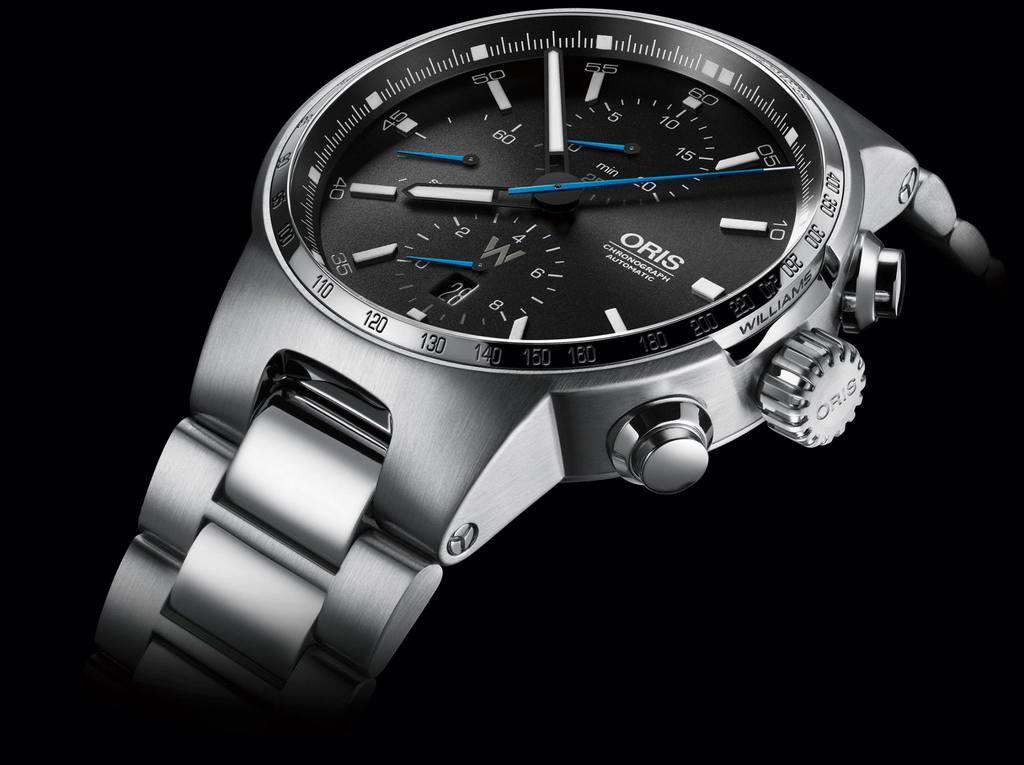Is that an oris watch?
Your response must be concise. Yes. What time is on the watch?
Offer a terse response. 7:53. 